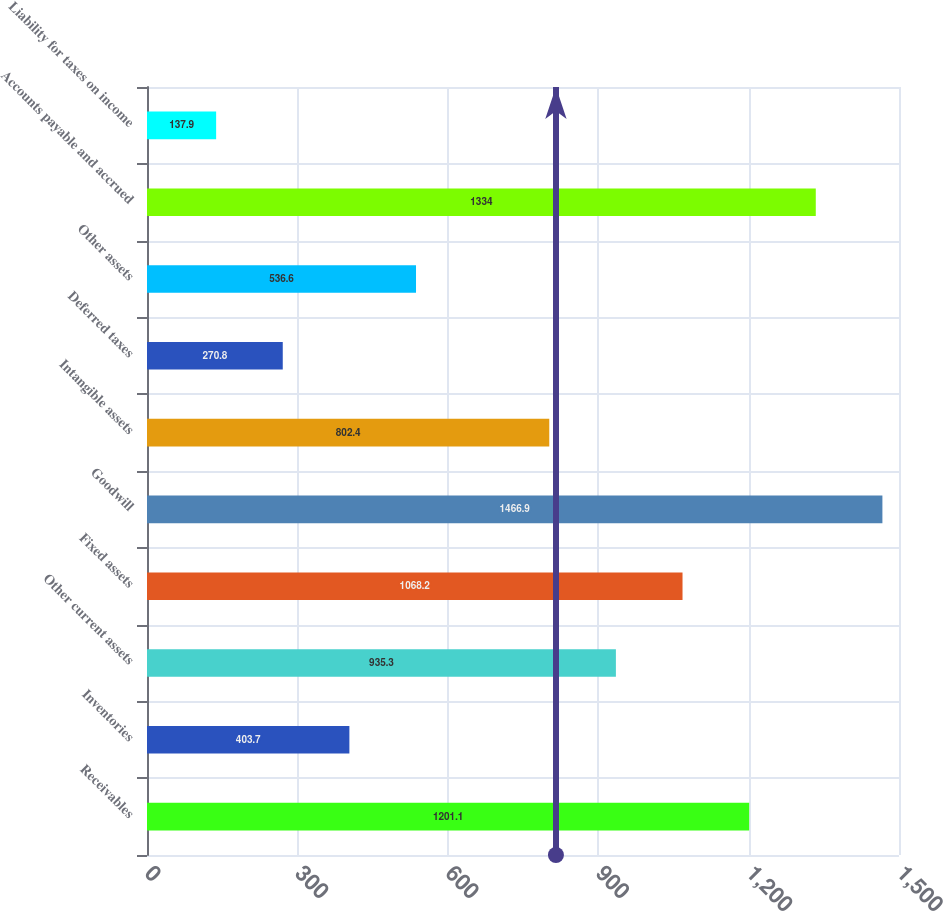<chart> <loc_0><loc_0><loc_500><loc_500><bar_chart><fcel>Receivables<fcel>Inventories<fcel>Other current assets<fcel>Fixed assets<fcel>Goodwill<fcel>Intangible assets<fcel>Deferred taxes<fcel>Other assets<fcel>Accounts payable and accrued<fcel>Liability for taxes on income<nl><fcel>1201.1<fcel>403.7<fcel>935.3<fcel>1068.2<fcel>1466.9<fcel>802.4<fcel>270.8<fcel>536.6<fcel>1334<fcel>137.9<nl></chart> 